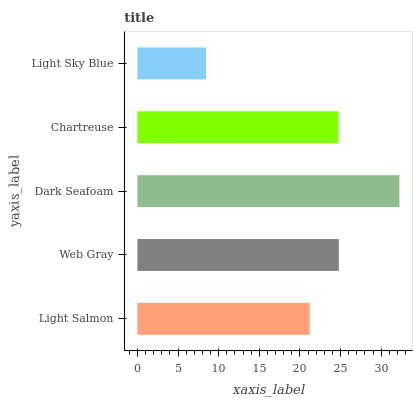Is Light Sky Blue the minimum?
Answer yes or no. Yes. Is Dark Seafoam the maximum?
Answer yes or no. Yes. Is Web Gray the minimum?
Answer yes or no. No. Is Web Gray the maximum?
Answer yes or no. No. Is Web Gray greater than Light Salmon?
Answer yes or no. Yes. Is Light Salmon less than Web Gray?
Answer yes or no. Yes. Is Light Salmon greater than Web Gray?
Answer yes or no. No. Is Web Gray less than Light Salmon?
Answer yes or no. No. Is Chartreuse the high median?
Answer yes or no. Yes. Is Chartreuse the low median?
Answer yes or no. Yes. Is Dark Seafoam the high median?
Answer yes or no. No. Is Web Gray the low median?
Answer yes or no. No. 